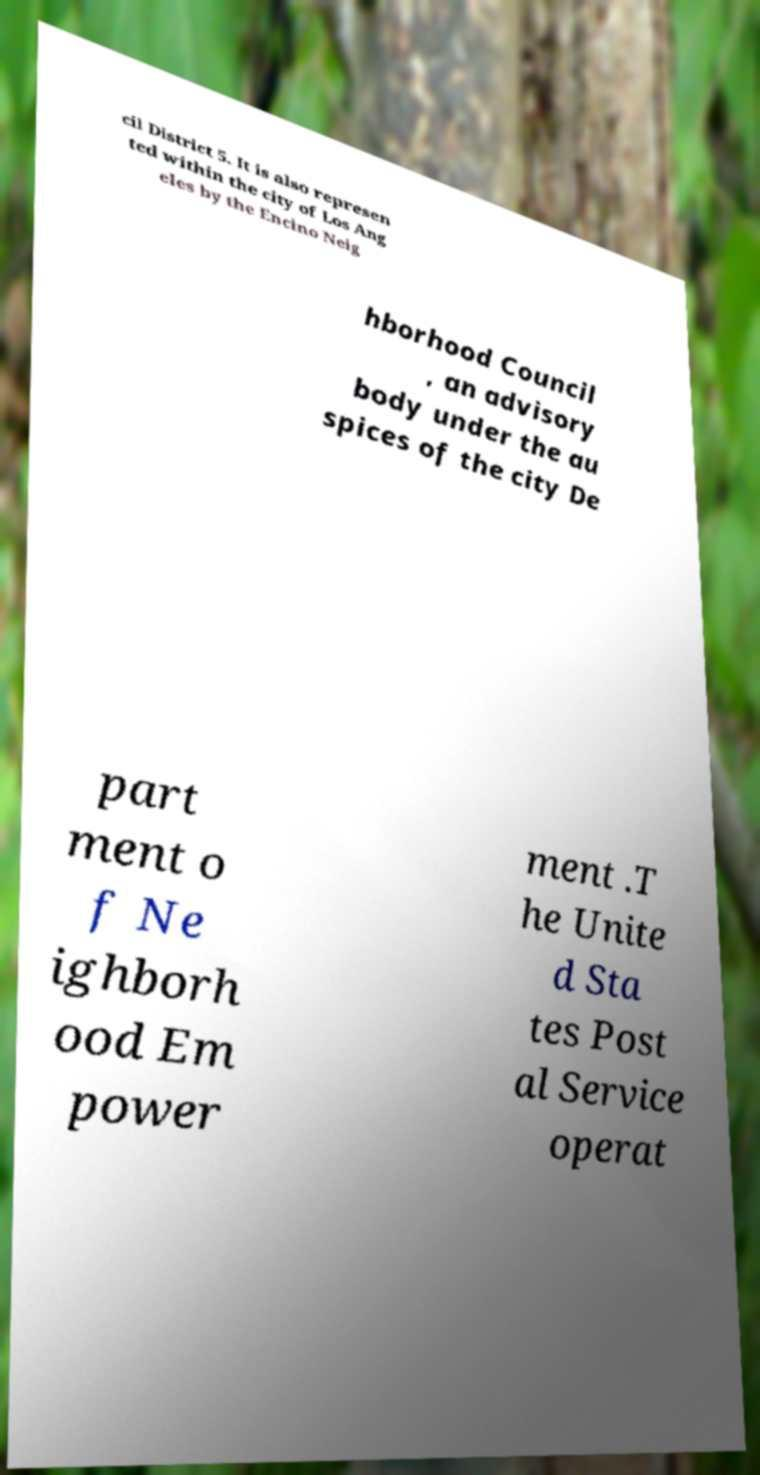Please identify and transcribe the text found in this image. cil District 5. It is also represen ted within the city of Los Ang eles by the Encino Neig hborhood Council , an advisory body under the au spices of the city De part ment o f Ne ighborh ood Em power ment .T he Unite d Sta tes Post al Service operat 